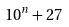<formula> <loc_0><loc_0><loc_500><loc_500>1 0 ^ { n } + 2 7</formula> 